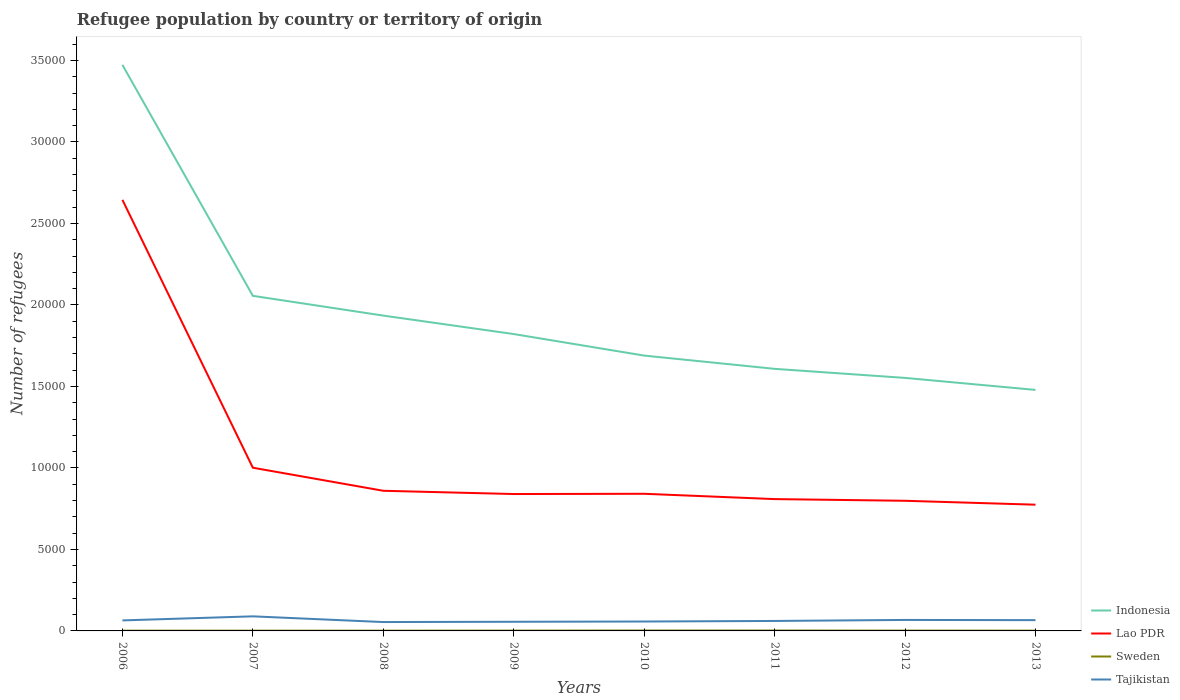Is the number of lines equal to the number of legend labels?
Provide a short and direct response. Yes. Across all years, what is the maximum number of refugees in Tajikistan?
Make the answer very short. 544. What is the total number of refugees in Indonesia in the graph?
Your answer should be compact. 1.65e+04. How many lines are there?
Offer a terse response. 4. How many years are there in the graph?
Offer a very short reply. 8. What is the difference between two consecutive major ticks on the Y-axis?
Provide a short and direct response. 5000. Are the values on the major ticks of Y-axis written in scientific E-notation?
Give a very brief answer. No. Does the graph contain any zero values?
Offer a very short reply. No. Does the graph contain grids?
Provide a short and direct response. No. Where does the legend appear in the graph?
Offer a terse response. Bottom right. How many legend labels are there?
Ensure brevity in your answer.  4. How are the legend labels stacked?
Provide a succinct answer. Vertical. What is the title of the graph?
Make the answer very short. Refugee population by country or territory of origin. What is the label or title of the X-axis?
Your response must be concise. Years. What is the label or title of the Y-axis?
Your response must be concise. Number of refugees. What is the Number of refugees of Indonesia in 2006?
Offer a terse response. 3.47e+04. What is the Number of refugees in Lao PDR in 2006?
Your response must be concise. 2.64e+04. What is the Number of refugees of Sweden in 2006?
Provide a succinct answer. 16. What is the Number of refugees of Tajikistan in 2006?
Your answer should be very brief. 645. What is the Number of refugees in Indonesia in 2007?
Provide a succinct answer. 2.06e+04. What is the Number of refugees in Lao PDR in 2007?
Provide a succinct answer. 1.00e+04. What is the Number of refugees of Sweden in 2007?
Your answer should be very brief. 16. What is the Number of refugees of Tajikistan in 2007?
Offer a terse response. 894. What is the Number of refugees in Indonesia in 2008?
Offer a very short reply. 1.93e+04. What is the Number of refugees in Lao PDR in 2008?
Make the answer very short. 8598. What is the Number of refugees of Tajikistan in 2008?
Provide a short and direct response. 544. What is the Number of refugees of Indonesia in 2009?
Make the answer very short. 1.82e+04. What is the Number of refugees of Lao PDR in 2009?
Make the answer very short. 8398. What is the Number of refugees in Tajikistan in 2009?
Ensure brevity in your answer.  562. What is the Number of refugees in Indonesia in 2010?
Keep it short and to the point. 1.69e+04. What is the Number of refugees of Lao PDR in 2010?
Keep it short and to the point. 8414. What is the Number of refugees of Sweden in 2010?
Make the answer very short. 25. What is the Number of refugees in Tajikistan in 2010?
Ensure brevity in your answer.  577. What is the Number of refugees of Indonesia in 2011?
Offer a terse response. 1.61e+04. What is the Number of refugees in Lao PDR in 2011?
Ensure brevity in your answer.  8088. What is the Number of refugees in Sweden in 2011?
Make the answer very short. 24. What is the Number of refugees of Tajikistan in 2011?
Provide a succinct answer. 612. What is the Number of refugees in Indonesia in 2012?
Offer a very short reply. 1.55e+04. What is the Number of refugees of Lao PDR in 2012?
Ensure brevity in your answer.  7984. What is the Number of refugees of Sweden in 2012?
Offer a terse response. 20. What is the Number of refugees in Tajikistan in 2012?
Ensure brevity in your answer.  674. What is the Number of refugees of Indonesia in 2013?
Provide a succinct answer. 1.48e+04. What is the Number of refugees in Lao PDR in 2013?
Your answer should be very brief. 7745. What is the Number of refugees in Sweden in 2013?
Make the answer very short. 17. What is the Number of refugees of Tajikistan in 2013?
Offer a very short reply. 661. Across all years, what is the maximum Number of refugees in Indonesia?
Your answer should be very brief. 3.47e+04. Across all years, what is the maximum Number of refugees of Lao PDR?
Your answer should be compact. 2.64e+04. Across all years, what is the maximum Number of refugees of Sweden?
Ensure brevity in your answer.  25. Across all years, what is the maximum Number of refugees in Tajikistan?
Your answer should be compact. 894. Across all years, what is the minimum Number of refugees of Indonesia?
Provide a succinct answer. 1.48e+04. Across all years, what is the minimum Number of refugees of Lao PDR?
Provide a succinct answer. 7745. Across all years, what is the minimum Number of refugees of Tajikistan?
Your answer should be compact. 544. What is the total Number of refugees in Indonesia in the graph?
Offer a very short reply. 1.56e+05. What is the total Number of refugees of Lao PDR in the graph?
Your answer should be very brief. 8.57e+04. What is the total Number of refugees in Sweden in the graph?
Keep it short and to the point. 152. What is the total Number of refugees in Tajikistan in the graph?
Give a very brief answer. 5169. What is the difference between the Number of refugees in Indonesia in 2006 and that in 2007?
Make the answer very short. 1.42e+04. What is the difference between the Number of refugees in Lao PDR in 2006 and that in 2007?
Provide a succinct answer. 1.64e+04. What is the difference between the Number of refugees of Sweden in 2006 and that in 2007?
Make the answer very short. 0. What is the difference between the Number of refugees of Tajikistan in 2006 and that in 2007?
Your answer should be very brief. -249. What is the difference between the Number of refugees of Indonesia in 2006 and that in 2008?
Give a very brief answer. 1.54e+04. What is the difference between the Number of refugees in Lao PDR in 2006 and that in 2008?
Offer a very short reply. 1.78e+04. What is the difference between the Number of refugees in Sweden in 2006 and that in 2008?
Make the answer very short. 1. What is the difference between the Number of refugees in Tajikistan in 2006 and that in 2008?
Offer a terse response. 101. What is the difference between the Number of refugees of Indonesia in 2006 and that in 2009?
Your answer should be compact. 1.65e+04. What is the difference between the Number of refugees of Lao PDR in 2006 and that in 2009?
Keep it short and to the point. 1.80e+04. What is the difference between the Number of refugees of Indonesia in 2006 and that in 2010?
Make the answer very short. 1.78e+04. What is the difference between the Number of refugees in Lao PDR in 2006 and that in 2010?
Ensure brevity in your answer.  1.80e+04. What is the difference between the Number of refugees of Sweden in 2006 and that in 2010?
Provide a succinct answer. -9. What is the difference between the Number of refugees in Tajikistan in 2006 and that in 2010?
Provide a short and direct response. 68. What is the difference between the Number of refugees of Indonesia in 2006 and that in 2011?
Keep it short and to the point. 1.86e+04. What is the difference between the Number of refugees in Lao PDR in 2006 and that in 2011?
Offer a terse response. 1.84e+04. What is the difference between the Number of refugees in Sweden in 2006 and that in 2011?
Offer a terse response. -8. What is the difference between the Number of refugees of Tajikistan in 2006 and that in 2011?
Your response must be concise. 33. What is the difference between the Number of refugees of Indonesia in 2006 and that in 2012?
Offer a terse response. 1.92e+04. What is the difference between the Number of refugees of Lao PDR in 2006 and that in 2012?
Give a very brief answer. 1.85e+04. What is the difference between the Number of refugees in Tajikistan in 2006 and that in 2012?
Offer a very short reply. -29. What is the difference between the Number of refugees in Indonesia in 2006 and that in 2013?
Keep it short and to the point. 1.99e+04. What is the difference between the Number of refugees in Lao PDR in 2006 and that in 2013?
Your response must be concise. 1.87e+04. What is the difference between the Number of refugees in Indonesia in 2007 and that in 2008?
Give a very brief answer. 1213. What is the difference between the Number of refugees of Lao PDR in 2007 and that in 2008?
Your answer should be compact. 1415. What is the difference between the Number of refugees of Sweden in 2007 and that in 2008?
Provide a short and direct response. 1. What is the difference between the Number of refugees of Tajikistan in 2007 and that in 2008?
Make the answer very short. 350. What is the difference between the Number of refugees in Indonesia in 2007 and that in 2009?
Your answer should be very brief. 2345. What is the difference between the Number of refugees of Lao PDR in 2007 and that in 2009?
Give a very brief answer. 1615. What is the difference between the Number of refugees in Tajikistan in 2007 and that in 2009?
Offer a very short reply. 332. What is the difference between the Number of refugees of Indonesia in 2007 and that in 2010?
Provide a short and direct response. 3666. What is the difference between the Number of refugees in Lao PDR in 2007 and that in 2010?
Provide a succinct answer. 1599. What is the difference between the Number of refugees of Sweden in 2007 and that in 2010?
Ensure brevity in your answer.  -9. What is the difference between the Number of refugees in Tajikistan in 2007 and that in 2010?
Your answer should be compact. 317. What is the difference between the Number of refugees in Indonesia in 2007 and that in 2011?
Your answer should be compact. 4479. What is the difference between the Number of refugees in Lao PDR in 2007 and that in 2011?
Your answer should be very brief. 1925. What is the difference between the Number of refugees in Sweden in 2007 and that in 2011?
Offer a very short reply. -8. What is the difference between the Number of refugees in Tajikistan in 2007 and that in 2011?
Provide a short and direct response. 282. What is the difference between the Number of refugees in Indonesia in 2007 and that in 2012?
Your response must be concise. 5035. What is the difference between the Number of refugees of Lao PDR in 2007 and that in 2012?
Provide a short and direct response. 2029. What is the difference between the Number of refugees of Sweden in 2007 and that in 2012?
Provide a short and direct response. -4. What is the difference between the Number of refugees of Tajikistan in 2007 and that in 2012?
Offer a very short reply. 220. What is the difference between the Number of refugees in Indonesia in 2007 and that in 2013?
Provide a succinct answer. 5772. What is the difference between the Number of refugees of Lao PDR in 2007 and that in 2013?
Offer a very short reply. 2268. What is the difference between the Number of refugees in Tajikistan in 2007 and that in 2013?
Give a very brief answer. 233. What is the difference between the Number of refugees of Indonesia in 2008 and that in 2009?
Your answer should be compact. 1132. What is the difference between the Number of refugees of Lao PDR in 2008 and that in 2009?
Ensure brevity in your answer.  200. What is the difference between the Number of refugees of Indonesia in 2008 and that in 2010?
Your answer should be compact. 2453. What is the difference between the Number of refugees in Lao PDR in 2008 and that in 2010?
Offer a terse response. 184. What is the difference between the Number of refugees of Tajikistan in 2008 and that in 2010?
Your answer should be very brief. -33. What is the difference between the Number of refugees of Indonesia in 2008 and that in 2011?
Give a very brief answer. 3266. What is the difference between the Number of refugees of Lao PDR in 2008 and that in 2011?
Ensure brevity in your answer.  510. What is the difference between the Number of refugees in Tajikistan in 2008 and that in 2011?
Provide a short and direct response. -68. What is the difference between the Number of refugees of Indonesia in 2008 and that in 2012?
Your answer should be very brief. 3822. What is the difference between the Number of refugees in Lao PDR in 2008 and that in 2012?
Your response must be concise. 614. What is the difference between the Number of refugees in Sweden in 2008 and that in 2012?
Offer a very short reply. -5. What is the difference between the Number of refugees of Tajikistan in 2008 and that in 2012?
Keep it short and to the point. -130. What is the difference between the Number of refugees in Indonesia in 2008 and that in 2013?
Ensure brevity in your answer.  4559. What is the difference between the Number of refugees of Lao PDR in 2008 and that in 2013?
Your answer should be very brief. 853. What is the difference between the Number of refugees in Tajikistan in 2008 and that in 2013?
Offer a very short reply. -117. What is the difference between the Number of refugees of Indonesia in 2009 and that in 2010?
Make the answer very short. 1321. What is the difference between the Number of refugees in Lao PDR in 2009 and that in 2010?
Offer a terse response. -16. What is the difference between the Number of refugees in Tajikistan in 2009 and that in 2010?
Make the answer very short. -15. What is the difference between the Number of refugees of Indonesia in 2009 and that in 2011?
Offer a very short reply. 2134. What is the difference between the Number of refugees of Lao PDR in 2009 and that in 2011?
Offer a terse response. 310. What is the difference between the Number of refugees in Tajikistan in 2009 and that in 2011?
Ensure brevity in your answer.  -50. What is the difference between the Number of refugees of Indonesia in 2009 and that in 2012?
Ensure brevity in your answer.  2690. What is the difference between the Number of refugees of Lao PDR in 2009 and that in 2012?
Offer a very short reply. 414. What is the difference between the Number of refugees in Sweden in 2009 and that in 2012?
Provide a short and direct response. -1. What is the difference between the Number of refugees in Tajikistan in 2009 and that in 2012?
Keep it short and to the point. -112. What is the difference between the Number of refugees in Indonesia in 2009 and that in 2013?
Ensure brevity in your answer.  3427. What is the difference between the Number of refugees of Lao PDR in 2009 and that in 2013?
Offer a terse response. 653. What is the difference between the Number of refugees in Sweden in 2009 and that in 2013?
Your response must be concise. 2. What is the difference between the Number of refugees of Tajikistan in 2009 and that in 2013?
Make the answer very short. -99. What is the difference between the Number of refugees in Indonesia in 2010 and that in 2011?
Offer a terse response. 813. What is the difference between the Number of refugees of Lao PDR in 2010 and that in 2011?
Make the answer very short. 326. What is the difference between the Number of refugees in Tajikistan in 2010 and that in 2011?
Provide a succinct answer. -35. What is the difference between the Number of refugees in Indonesia in 2010 and that in 2012?
Offer a terse response. 1369. What is the difference between the Number of refugees of Lao PDR in 2010 and that in 2012?
Your answer should be very brief. 430. What is the difference between the Number of refugees of Tajikistan in 2010 and that in 2012?
Make the answer very short. -97. What is the difference between the Number of refugees in Indonesia in 2010 and that in 2013?
Keep it short and to the point. 2106. What is the difference between the Number of refugees in Lao PDR in 2010 and that in 2013?
Your answer should be very brief. 669. What is the difference between the Number of refugees in Sweden in 2010 and that in 2013?
Give a very brief answer. 8. What is the difference between the Number of refugees of Tajikistan in 2010 and that in 2013?
Ensure brevity in your answer.  -84. What is the difference between the Number of refugees of Indonesia in 2011 and that in 2012?
Your answer should be very brief. 556. What is the difference between the Number of refugees in Lao PDR in 2011 and that in 2012?
Make the answer very short. 104. What is the difference between the Number of refugees of Tajikistan in 2011 and that in 2012?
Keep it short and to the point. -62. What is the difference between the Number of refugees of Indonesia in 2011 and that in 2013?
Make the answer very short. 1293. What is the difference between the Number of refugees of Lao PDR in 2011 and that in 2013?
Ensure brevity in your answer.  343. What is the difference between the Number of refugees in Sweden in 2011 and that in 2013?
Provide a succinct answer. 7. What is the difference between the Number of refugees of Tajikistan in 2011 and that in 2013?
Provide a short and direct response. -49. What is the difference between the Number of refugees of Indonesia in 2012 and that in 2013?
Provide a short and direct response. 737. What is the difference between the Number of refugees in Lao PDR in 2012 and that in 2013?
Ensure brevity in your answer.  239. What is the difference between the Number of refugees of Indonesia in 2006 and the Number of refugees of Lao PDR in 2007?
Your response must be concise. 2.47e+04. What is the difference between the Number of refugees of Indonesia in 2006 and the Number of refugees of Sweden in 2007?
Ensure brevity in your answer.  3.47e+04. What is the difference between the Number of refugees of Indonesia in 2006 and the Number of refugees of Tajikistan in 2007?
Provide a short and direct response. 3.38e+04. What is the difference between the Number of refugees in Lao PDR in 2006 and the Number of refugees in Sweden in 2007?
Give a very brief answer. 2.64e+04. What is the difference between the Number of refugees of Lao PDR in 2006 and the Number of refugees of Tajikistan in 2007?
Provide a succinct answer. 2.56e+04. What is the difference between the Number of refugees in Sweden in 2006 and the Number of refugees in Tajikistan in 2007?
Offer a terse response. -878. What is the difference between the Number of refugees of Indonesia in 2006 and the Number of refugees of Lao PDR in 2008?
Ensure brevity in your answer.  2.61e+04. What is the difference between the Number of refugees of Indonesia in 2006 and the Number of refugees of Sweden in 2008?
Give a very brief answer. 3.47e+04. What is the difference between the Number of refugees of Indonesia in 2006 and the Number of refugees of Tajikistan in 2008?
Give a very brief answer. 3.42e+04. What is the difference between the Number of refugees of Lao PDR in 2006 and the Number of refugees of Sweden in 2008?
Keep it short and to the point. 2.64e+04. What is the difference between the Number of refugees of Lao PDR in 2006 and the Number of refugees of Tajikistan in 2008?
Ensure brevity in your answer.  2.59e+04. What is the difference between the Number of refugees in Sweden in 2006 and the Number of refugees in Tajikistan in 2008?
Your answer should be compact. -528. What is the difference between the Number of refugees in Indonesia in 2006 and the Number of refugees in Lao PDR in 2009?
Offer a very short reply. 2.63e+04. What is the difference between the Number of refugees in Indonesia in 2006 and the Number of refugees in Sweden in 2009?
Offer a very short reply. 3.47e+04. What is the difference between the Number of refugees in Indonesia in 2006 and the Number of refugees in Tajikistan in 2009?
Ensure brevity in your answer.  3.42e+04. What is the difference between the Number of refugees in Lao PDR in 2006 and the Number of refugees in Sweden in 2009?
Ensure brevity in your answer.  2.64e+04. What is the difference between the Number of refugees in Lao PDR in 2006 and the Number of refugees in Tajikistan in 2009?
Make the answer very short. 2.59e+04. What is the difference between the Number of refugees of Sweden in 2006 and the Number of refugees of Tajikistan in 2009?
Ensure brevity in your answer.  -546. What is the difference between the Number of refugees in Indonesia in 2006 and the Number of refugees in Lao PDR in 2010?
Provide a succinct answer. 2.63e+04. What is the difference between the Number of refugees in Indonesia in 2006 and the Number of refugees in Sweden in 2010?
Keep it short and to the point. 3.47e+04. What is the difference between the Number of refugees of Indonesia in 2006 and the Number of refugees of Tajikistan in 2010?
Offer a terse response. 3.42e+04. What is the difference between the Number of refugees in Lao PDR in 2006 and the Number of refugees in Sweden in 2010?
Your response must be concise. 2.64e+04. What is the difference between the Number of refugees in Lao PDR in 2006 and the Number of refugees in Tajikistan in 2010?
Offer a terse response. 2.59e+04. What is the difference between the Number of refugees in Sweden in 2006 and the Number of refugees in Tajikistan in 2010?
Make the answer very short. -561. What is the difference between the Number of refugees in Indonesia in 2006 and the Number of refugees in Lao PDR in 2011?
Ensure brevity in your answer.  2.66e+04. What is the difference between the Number of refugees in Indonesia in 2006 and the Number of refugees in Sweden in 2011?
Your answer should be compact. 3.47e+04. What is the difference between the Number of refugees in Indonesia in 2006 and the Number of refugees in Tajikistan in 2011?
Your answer should be very brief. 3.41e+04. What is the difference between the Number of refugees of Lao PDR in 2006 and the Number of refugees of Sweden in 2011?
Your answer should be very brief. 2.64e+04. What is the difference between the Number of refugees in Lao PDR in 2006 and the Number of refugees in Tajikistan in 2011?
Provide a short and direct response. 2.58e+04. What is the difference between the Number of refugees in Sweden in 2006 and the Number of refugees in Tajikistan in 2011?
Your answer should be very brief. -596. What is the difference between the Number of refugees of Indonesia in 2006 and the Number of refugees of Lao PDR in 2012?
Keep it short and to the point. 2.67e+04. What is the difference between the Number of refugees of Indonesia in 2006 and the Number of refugees of Sweden in 2012?
Your answer should be compact. 3.47e+04. What is the difference between the Number of refugees in Indonesia in 2006 and the Number of refugees in Tajikistan in 2012?
Your answer should be very brief. 3.41e+04. What is the difference between the Number of refugees in Lao PDR in 2006 and the Number of refugees in Sweden in 2012?
Provide a short and direct response. 2.64e+04. What is the difference between the Number of refugees of Lao PDR in 2006 and the Number of refugees of Tajikistan in 2012?
Ensure brevity in your answer.  2.58e+04. What is the difference between the Number of refugees in Sweden in 2006 and the Number of refugees in Tajikistan in 2012?
Your answer should be very brief. -658. What is the difference between the Number of refugees of Indonesia in 2006 and the Number of refugees of Lao PDR in 2013?
Make the answer very short. 2.70e+04. What is the difference between the Number of refugees in Indonesia in 2006 and the Number of refugees in Sweden in 2013?
Give a very brief answer. 3.47e+04. What is the difference between the Number of refugees of Indonesia in 2006 and the Number of refugees of Tajikistan in 2013?
Make the answer very short. 3.41e+04. What is the difference between the Number of refugees in Lao PDR in 2006 and the Number of refugees in Sweden in 2013?
Keep it short and to the point. 2.64e+04. What is the difference between the Number of refugees in Lao PDR in 2006 and the Number of refugees in Tajikistan in 2013?
Ensure brevity in your answer.  2.58e+04. What is the difference between the Number of refugees of Sweden in 2006 and the Number of refugees of Tajikistan in 2013?
Provide a succinct answer. -645. What is the difference between the Number of refugees in Indonesia in 2007 and the Number of refugees in Lao PDR in 2008?
Provide a succinct answer. 1.20e+04. What is the difference between the Number of refugees of Indonesia in 2007 and the Number of refugees of Sweden in 2008?
Your answer should be compact. 2.05e+04. What is the difference between the Number of refugees of Indonesia in 2007 and the Number of refugees of Tajikistan in 2008?
Offer a terse response. 2.00e+04. What is the difference between the Number of refugees of Lao PDR in 2007 and the Number of refugees of Sweden in 2008?
Give a very brief answer. 9998. What is the difference between the Number of refugees of Lao PDR in 2007 and the Number of refugees of Tajikistan in 2008?
Your answer should be very brief. 9469. What is the difference between the Number of refugees of Sweden in 2007 and the Number of refugees of Tajikistan in 2008?
Your answer should be compact. -528. What is the difference between the Number of refugees of Indonesia in 2007 and the Number of refugees of Lao PDR in 2009?
Your answer should be compact. 1.22e+04. What is the difference between the Number of refugees in Indonesia in 2007 and the Number of refugees in Sweden in 2009?
Ensure brevity in your answer.  2.05e+04. What is the difference between the Number of refugees of Indonesia in 2007 and the Number of refugees of Tajikistan in 2009?
Your answer should be very brief. 2.00e+04. What is the difference between the Number of refugees of Lao PDR in 2007 and the Number of refugees of Sweden in 2009?
Keep it short and to the point. 9994. What is the difference between the Number of refugees in Lao PDR in 2007 and the Number of refugees in Tajikistan in 2009?
Your answer should be very brief. 9451. What is the difference between the Number of refugees of Sweden in 2007 and the Number of refugees of Tajikistan in 2009?
Your answer should be very brief. -546. What is the difference between the Number of refugees of Indonesia in 2007 and the Number of refugees of Lao PDR in 2010?
Make the answer very short. 1.21e+04. What is the difference between the Number of refugees in Indonesia in 2007 and the Number of refugees in Sweden in 2010?
Your answer should be compact. 2.05e+04. What is the difference between the Number of refugees in Indonesia in 2007 and the Number of refugees in Tajikistan in 2010?
Your answer should be compact. 2.00e+04. What is the difference between the Number of refugees of Lao PDR in 2007 and the Number of refugees of Sweden in 2010?
Offer a very short reply. 9988. What is the difference between the Number of refugees of Lao PDR in 2007 and the Number of refugees of Tajikistan in 2010?
Ensure brevity in your answer.  9436. What is the difference between the Number of refugees of Sweden in 2007 and the Number of refugees of Tajikistan in 2010?
Your answer should be compact. -561. What is the difference between the Number of refugees of Indonesia in 2007 and the Number of refugees of Lao PDR in 2011?
Offer a very short reply. 1.25e+04. What is the difference between the Number of refugees of Indonesia in 2007 and the Number of refugees of Sweden in 2011?
Offer a very short reply. 2.05e+04. What is the difference between the Number of refugees of Indonesia in 2007 and the Number of refugees of Tajikistan in 2011?
Give a very brief answer. 1.99e+04. What is the difference between the Number of refugees in Lao PDR in 2007 and the Number of refugees in Sweden in 2011?
Provide a short and direct response. 9989. What is the difference between the Number of refugees of Lao PDR in 2007 and the Number of refugees of Tajikistan in 2011?
Offer a terse response. 9401. What is the difference between the Number of refugees of Sweden in 2007 and the Number of refugees of Tajikistan in 2011?
Your response must be concise. -596. What is the difference between the Number of refugees in Indonesia in 2007 and the Number of refugees in Lao PDR in 2012?
Offer a very short reply. 1.26e+04. What is the difference between the Number of refugees in Indonesia in 2007 and the Number of refugees in Sweden in 2012?
Your response must be concise. 2.05e+04. What is the difference between the Number of refugees of Indonesia in 2007 and the Number of refugees of Tajikistan in 2012?
Offer a very short reply. 1.99e+04. What is the difference between the Number of refugees of Lao PDR in 2007 and the Number of refugees of Sweden in 2012?
Your answer should be very brief. 9993. What is the difference between the Number of refugees in Lao PDR in 2007 and the Number of refugees in Tajikistan in 2012?
Keep it short and to the point. 9339. What is the difference between the Number of refugees of Sweden in 2007 and the Number of refugees of Tajikistan in 2012?
Offer a terse response. -658. What is the difference between the Number of refugees of Indonesia in 2007 and the Number of refugees of Lao PDR in 2013?
Provide a short and direct response. 1.28e+04. What is the difference between the Number of refugees of Indonesia in 2007 and the Number of refugees of Sweden in 2013?
Keep it short and to the point. 2.05e+04. What is the difference between the Number of refugees in Indonesia in 2007 and the Number of refugees in Tajikistan in 2013?
Give a very brief answer. 1.99e+04. What is the difference between the Number of refugees of Lao PDR in 2007 and the Number of refugees of Sweden in 2013?
Provide a short and direct response. 9996. What is the difference between the Number of refugees in Lao PDR in 2007 and the Number of refugees in Tajikistan in 2013?
Provide a short and direct response. 9352. What is the difference between the Number of refugees in Sweden in 2007 and the Number of refugees in Tajikistan in 2013?
Give a very brief answer. -645. What is the difference between the Number of refugees of Indonesia in 2008 and the Number of refugees of Lao PDR in 2009?
Your response must be concise. 1.09e+04. What is the difference between the Number of refugees in Indonesia in 2008 and the Number of refugees in Sweden in 2009?
Offer a very short reply. 1.93e+04. What is the difference between the Number of refugees of Indonesia in 2008 and the Number of refugees of Tajikistan in 2009?
Provide a short and direct response. 1.88e+04. What is the difference between the Number of refugees in Lao PDR in 2008 and the Number of refugees in Sweden in 2009?
Your answer should be very brief. 8579. What is the difference between the Number of refugees of Lao PDR in 2008 and the Number of refugees of Tajikistan in 2009?
Your answer should be very brief. 8036. What is the difference between the Number of refugees in Sweden in 2008 and the Number of refugees in Tajikistan in 2009?
Provide a short and direct response. -547. What is the difference between the Number of refugees in Indonesia in 2008 and the Number of refugees in Lao PDR in 2010?
Your answer should be compact. 1.09e+04. What is the difference between the Number of refugees in Indonesia in 2008 and the Number of refugees in Sweden in 2010?
Offer a very short reply. 1.93e+04. What is the difference between the Number of refugees in Indonesia in 2008 and the Number of refugees in Tajikistan in 2010?
Offer a terse response. 1.88e+04. What is the difference between the Number of refugees in Lao PDR in 2008 and the Number of refugees in Sweden in 2010?
Your answer should be compact. 8573. What is the difference between the Number of refugees in Lao PDR in 2008 and the Number of refugees in Tajikistan in 2010?
Offer a terse response. 8021. What is the difference between the Number of refugees in Sweden in 2008 and the Number of refugees in Tajikistan in 2010?
Keep it short and to the point. -562. What is the difference between the Number of refugees of Indonesia in 2008 and the Number of refugees of Lao PDR in 2011?
Offer a very short reply. 1.13e+04. What is the difference between the Number of refugees in Indonesia in 2008 and the Number of refugees in Sweden in 2011?
Provide a succinct answer. 1.93e+04. What is the difference between the Number of refugees of Indonesia in 2008 and the Number of refugees of Tajikistan in 2011?
Your answer should be very brief. 1.87e+04. What is the difference between the Number of refugees in Lao PDR in 2008 and the Number of refugees in Sweden in 2011?
Provide a short and direct response. 8574. What is the difference between the Number of refugees of Lao PDR in 2008 and the Number of refugees of Tajikistan in 2011?
Offer a very short reply. 7986. What is the difference between the Number of refugees of Sweden in 2008 and the Number of refugees of Tajikistan in 2011?
Your answer should be very brief. -597. What is the difference between the Number of refugees of Indonesia in 2008 and the Number of refugees of Lao PDR in 2012?
Give a very brief answer. 1.14e+04. What is the difference between the Number of refugees in Indonesia in 2008 and the Number of refugees in Sweden in 2012?
Your response must be concise. 1.93e+04. What is the difference between the Number of refugees in Indonesia in 2008 and the Number of refugees in Tajikistan in 2012?
Your answer should be very brief. 1.87e+04. What is the difference between the Number of refugees in Lao PDR in 2008 and the Number of refugees in Sweden in 2012?
Give a very brief answer. 8578. What is the difference between the Number of refugees of Lao PDR in 2008 and the Number of refugees of Tajikistan in 2012?
Your response must be concise. 7924. What is the difference between the Number of refugees in Sweden in 2008 and the Number of refugees in Tajikistan in 2012?
Make the answer very short. -659. What is the difference between the Number of refugees of Indonesia in 2008 and the Number of refugees of Lao PDR in 2013?
Your response must be concise. 1.16e+04. What is the difference between the Number of refugees of Indonesia in 2008 and the Number of refugees of Sweden in 2013?
Give a very brief answer. 1.93e+04. What is the difference between the Number of refugees of Indonesia in 2008 and the Number of refugees of Tajikistan in 2013?
Make the answer very short. 1.87e+04. What is the difference between the Number of refugees in Lao PDR in 2008 and the Number of refugees in Sweden in 2013?
Give a very brief answer. 8581. What is the difference between the Number of refugees in Lao PDR in 2008 and the Number of refugees in Tajikistan in 2013?
Your answer should be compact. 7937. What is the difference between the Number of refugees of Sweden in 2008 and the Number of refugees of Tajikistan in 2013?
Keep it short and to the point. -646. What is the difference between the Number of refugees of Indonesia in 2009 and the Number of refugees of Lao PDR in 2010?
Make the answer very short. 9799. What is the difference between the Number of refugees of Indonesia in 2009 and the Number of refugees of Sweden in 2010?
Your answer should be compact. 1.82e+04. What is the difference between the Number of refugees of Indonesia in 2009 and the Number of refugees of Tajikistan in 2010?
Provide a short and direct response. 1.76e+04. What is the difference between the Number of refugees of Lao PDR in 2009 and the Number of refugees of Sweden in 2010?
Give a very brief answer. 8373. What is the difference between the Number of refugees of Lao PDR in 2009 and the Number of refugees of Tajikistan in 2010?
Make the answer very short. 7821. What is the difference between the Number of refugees of Sweden in 2009 and the Number of refugees of Tajikistan in 2010?
Offer a very short reply. -558. What is the difference between the Number of refugees of Indonesia in 2009 and the Number of refugees of Lao PDR in 2011?
Offer a very short reply. 1.01e+04. What is the difference between the Number of refugees in Indonesia in 2009 and the Number of refugees in Sweden in 2011?
Offer a very short reply. 1.82e+04. What is the difference between the Number of refugees of Indonesia in 2009 and the Number of refugees of Tajikistan in 2011?
Your answer should be very brief. 1.76e+04. What is the difference between the Number of refugees in Lao PDR in 2009 and the Number of refugees in Sweden in 2011?
Your answer should be compact. 8374. What is the difference between the Number of refugees of Lao PDR in 2009 and the Number of refugees of Tajikistan in 2011?
Give a very brief answer. 7786. What is the difference between the Number of refugees of Sweden in 2009 and the Number of refugees of Tajikistan in 2011?
Provide a short and direct response. -593. What is the difference between the Number of refugees in Indonesia in 2009 and the Number of refugees in Lao PDR in 2012?
Your answer should be compact. 1.02e+04. What is the difference between the Number of refugees of Indonesia in 2009 and the Number of refugees of Sweden in 2012?
Offer a terse response. 1.82e+04. What is the difference between the Number of refugees of Indonesia in 2009 and the Number of refugees of Tajikistan in 2012?
Offer a terse response. 1.75e+04. What is the difference between the Number of refugees of Lao PDR in 2009 and the Number of refugees of Sweden in 2012?
Ensure brevity in your answer.  8378. What is the difference between the Number of refugees of Lao PDR in 2009 and the Number of refugees of Tajikistan in 2012?
Ensure brevity in your answer.  7724. What is the difference between the Number of refugees in Sweden in 2009 and the Number of refugees in Tajikistan in 2012?
Your answer should be very brief. -655. What is the difference between the Number of refugees in Indonesia in 2009 and the Number of refugees in Lao PDR in 2013?
Provide a succinct answer. 1.05e+04. What is the difference between the Number of refugees in Indonesia in 2009 and the Number of refugees in Sweden in 2013?
Provide a succinct answer. 1.82e+04. What is the difference between the Number of refugees of Indonesia in 2009 and the Number of refugees of Tajikistan in 2013?
Give a very brief answer. 1.76e+04. What is the difference between the Number of refugees in Lao PDR in 2009 and the Number of refugees in Sweden in 2013?
Ensure brevity in your answer.  8381. What is the difference between the Number of refugees in Lao PDR in 2009 and the Number of refugees in Tajikistan in 2013?
Offer a very short reply. 7737. What is the difference between the Number of refugees of Sweden in 2009 and the Number of refugees of Tajikistan in 2013?
Offer a terse response. -642. What is the difference between the Number of refugees in Indonesia in 2010 and the Number of refugees in Lao PDR in 2011?
Offer a very short reply. 8804. What is the difference between the Number of refugees of Indonesia in 2010 and the Number of refugees of Sweden in 2011?
Your response must be concise. 1.69e+04. What is the difference between the Number of refugees of Indonesia in 2010 and the Number of refugees of Tajikistan in 2011?
Your answer should be compact. 1.63e+04. What is the difference between the Number of refugees in Lao PDR in 2010 and the Number of refugees in Sweden in 2011?
Your answer should be very brief. 8390. What is the difference between the Number of refugees in Lao PDR in 2010 and the Number of refugees in Tajikistan in 2011?
Your answer should be very brief. 7802. What is the difference between the Number of refugees in Sweden in 2010 and the Number of refugees in Tajikistan in 2011?
Offer a terse response. -587. What is the difference between the Number of refugees in Indonesia in 2010 and the Number of refugees in Lao PDR in 2012?
Offer a very short reply. 8908. What is the difference between the Number of refugees of Indonesia in 2010 and the Number of refugees of Sweden in 2012?
Provide a succinct answer. 1.69e+04. What is the difference between the Number of refugees of Indonesia in 2010 and the Number of refugees of Tajikistan in 2012?
Give a very brief answer. 1.62e+04. What is the difference between the Number of refugees of Lao PDR in 2010 and the Number of refugees of Sweden in 2012?
Your response must be concise. 8394. What is the difference between the Number of refugees in Lao PDR in 2010 and the Number of refugees in Tajikistan in 2012?
Your answer should be very brief. 7740. What is the difference between the Number of refugees of Sweden in 2010 and the Number of refugees of Tajikistan in 2012?
Give a very brief answer. -649. What is the difference between the Number of refugees of Indonesia in 2010 and the Number of refugees of Lao PDR in 2013?
Your answer should be very brief. 9147. What is the difference between the Number of refugees in Indonesia in 2010 and the Number of refugees in Sweden in 2013?
Make the answer very short. 1.69e+04. What is the difference between the Number of refugees of Indonesia in 2010 and the Number of refugees of Tajikistan in 2013?
Make the answer very short. 1.62e+04. What is the difference between the Number of refugees in Lao PDR in 2010 and the Number of refugees in Sweden in 2013?
Your response must be concise. 8397. What is the difference between the Number of refugees of Lao PDR in 2010 and the Number of refugees of Tajikistan in 2013?
Offer a very short reply. 7753. What is the difference between the Number of refugees in Sweden in 2010 and the Number of refugees in Tajikistan in 2013?
Provide a short and direct response. -636. What is the difference between the Number of refugees of Indonesia in 2011 and the Number of refugees of Lao PDR in 2012?
Offer a terse response. 8095. What is the difference between the Number of refugees of Indonesia in 2011 and the Number of refugees of Sweden in 2012?
Provide a succinct answer. 1.61e+04. What is the difference between the Number of refugees of Indonesia in 2011 and the Number of refugees of Tajikistan in 2012?
Your answer should be compact. 1.54e+04. What is the difference between the Number of refugees of Lao PDR in 2011 and the Number of refugees of Sweden in 2012?
Ensure brevity in your answer.  8068. What is the difference between the Number of refugees in Lao PDR in 2011 and the Number of refugees in Tajikistan in 2012?
Give a very brief answer. 7414. What is the difference between the Number of refugees of Sweden in 2011 and the Number of refugees of Tajikistan in 2012?
Your response must be concise. -650. What is the difference between the Number of refugees of Indonesia in 2011 and the Number of refugees of Lao PDR in 2013?
Provide a succinct answer. 8334. What is the difference between the Number of refugees in Indonesia in 2011 and the Number of refugees in Sweden in 2013?
Provide a short and direct response. 1.61e+04. What is the difference between the Number of refugees in Indonesia in 2011 and the Number of refugees in Tajikistan in 2013?
Your response must be concise. 1.54e+04. What is the difference between the Number of refugees of Lao PDR in 2011 and the Number of refugees of Sweden in 2013?
Keep it short and to the point. 8071. What is the difference between the Number of refugees in Lao PDR in 2011 and the Number of refugees in Tajikistan in 2013?
Provide a short and direct response. 7427. What is the difference between the Number of refugees in Sweden in 2011 and the Number of refugees in Tajikistan in 2013?
Make the answer very short. -637. What is the difference between the Number of refugees in Indonesia in 2012 and the Number of refugees in Lao PDR in 2013?
Ensure brevity in your answer.  7778. What is the difference between the Number of refugees of Indonesia in 2012 and the Number of refugees of Sweden in 2013?
Offer a very short reply. 1.55e+04. What is the difference between the Number of refugees of Indonesia in 2012 and the Number of refugees of Tajikistan in 2013?
Make the answer very short. 1.49e+04. What is the difference between the Number of refugees of Lao PDR in 2012 and the Number of refugees of Sweden in 2013?
Offer a very short reply. 7967. What is the difference between the Number of refugees in Lao PDR in 2012 and the Number of refugees in Tajikistan in 2013?
Your response must be concise. 7323. What is the difference between the Number of refugees of Sweden in 2012 and the Number of refugees of Tajikistan in 2013?
Give a very brief answer. -641. What is the average Number of refugees of Indonesia per year?
Give a very brief answer. 1.95e+04. What is the average Number of refugees of Lao PDR per year?
Your answer should be compact. 1.07e+04. What is the average Number of refugees in Tajikistan per year?
Make the answer very short. 646.12. In the year 2006, what is the difference between the Number of refugees of Indonesia and Number of refugees of Lao PDR?
Your answer should be compact. 8281. In the year 2006, what is the difference between the Number of refugees in Indonesia and Number of refugees in Sweden?
Ensure brevity in your answer.  3.47e+04. In the year 2006, what is the difference between the Number of refugees in Indonesia and Number of refugees in Tajikistan?
Provide a succinct answer. 3.41e+04. In the year 2006, what is the difference between the Number of refugees of Lao PDR and Number of refugees of Sweden?
Provide a short and direct response. 2.64e+04. In the year 2006, what is the difference between the Number of refugees in Lao PDR and Number of refugees in Tajikistan?
Ensure brevity in your answer.  2.58e+04. In the year 2006, what is the difference between the Number of refugees in Sweden and Number of refugees in Tajikistan?
Offer a very short reply. -629. In the year 2007, what is the difference between the Number of refugees of Indonesia and Number of refugees of Lao PDR?
Keep it short and to the point. 1.05e+04. In the year 2007, what is the difference between the Number of refugees of Indonesia and Number of refugees of Sweden?
Provide a short and direct response. 2.05e+04. In the year 2007, what is the difference between the Number of refugees of Indonesia and Number of refugees of Tajikistan?
Provide a short and direct response. 1.97e+04. In the year 2007, what is the difference between the Number of refugees of Lao PDR and Number of refugees of Sweden?
Make the answer very short. 9997. In the year 2007, what is the difference between the Number of refugees in Lao PDR and Number of refugees in Tajikistan?
Your response must be concise. 9119. In the year 2007, what is the difference between the Number of refugees in Sweden and Number of refugees in Tajikistan?
Keep it short and to the point. -878. In the year 2008, what is the difference between the Number of refugees of Indonesia and Number of refugees of Lao PDR?
Provide a succinct answer. 1.07e+04. In the year 2008, what is the difference between the Number of refugees in Indonesia and Number of refugees in Sweden?
Make the answer very short. 1.93e+04. In the year 2008, what is the difference between the Number of refugees of Indonesia and Number of refugees of Tajikistan?
Your answer should be compact. 1.88e+04. In the year 2008, what is the difference between the Number of refugees of Lao PDR and Number of refugees of Sweden?
Give a very brief answer. 8583. In the year 2008, what is the difference between the Number of refugees in Lao PDR and Number of refugees in Tajikistan?
Offer a very short reply. 8054. In the year 2008, what is the difference between the Number of refugees of Sweden and Number of refugees of Tajikistan?
Your answer should be very brief. -529. In the year 2009, what is the difference between the Number of refugees in Indonesia and Number of refugees in Lao PDR?
Offer a very short reply. 9815. In the year 2009, what is the difference between the Number of refugees of Indonesia and Number of refugees of Sweden?
Ensure brevity in your answer.  1.82e+04. In the year 2009, what is the difference between the Number of refugees of Indonesia and Number of refugees of Tajikistan?
Give a very brief answer. 1.77e+04. In the year 2009, what is the difference between the Number of refugees in Lao PDR and Number of refugees in Sweden?
Offer a terse response. 8379. In the year 2009, what is the difference between the Number of refugees of Lao PDR and Number of refugees of Tajikistan?
Provide a succinct answer. 7836. In the year 2009, what is the difference between the Number of refugees in Sweden and Number of refugees in Tajikistan?
Your answer should be compact. -543. In the year 2010, what is the difference between the Number of refugees in Indonesia and Number of refugees in Lao PDR?
Your answer should be very brief. 8478. In the year 2010, what is the difference between the Number of refugees in Indonesia and Number of refugees in Sweden?
Offer a very short reply. 1.69e+04. In the year 2010, what is the difference between the Number of refugees in Indonesia and Number of refugees in Tajikistan?
Keep it short and to the point. 1.63e+04. In the year 2010, what is the difference between the Number of refugees of Lao PDR and Number of refugees of Sweden?
Provide a short and direct response. 8389. In the year 2010, what is the difference between the Number of refugees of Lao PDR and Number of refugees of Tajikistan?
Your response must be concise. 7837. In the year 2010, what is the difference between the Number of refugees in Sweden and Number of refugees in Tajikistan?
Provide a short and direct response. -552. In the year 2011, what is the difference between the Number of refugees in Indonesia and Number of refugees in Lao PDR?
Your response must be concise. 7991. In the year 2011, what is the difference between the Number of refugees in Indonesia and Number of refugees in Sweden?
Keep it short and to the point. 1.61e+04. In the year 2011, what is the difference between the Number of refugees in Indonesia and Number of refugees in Tajikistan?
Keep it short and to the point. 1.55e+04. In the year 2011, what is the difference between the Number of refugees in Lao PDR and Number of refugees in Sweden?
Keep it short and to the point. 8064. In the year 2011, what is the difference between the Number of refugees in Lao PDR and Number of refugees in Tajikistan?
Offer a terse response. 7476. In the year 2011, what is the difference between the Number of refugees of Sweden and Number of refugees of Tajikistan?
Provide a short and direct response. -588. In the year 2012, what is the difference between the Number of refugees in Indonesia and Number of refugees in Lao PDR?
Offer a very short reply. 7539. In the year 2012, what is the difference between the Number of refugees in Indonesia and Number of refugees in Sweden?
Make the answer very short. 1.55e+04. In the year 2012, what is the difference between the Number of refugees in Indonesia and Number of refugees in Tajikistan?
Keep it short and to the point. 1.48e+04. In the year 2012, what is the difference between the Number of refugees of Lao PDR and Number of refugees of Sweden?
Give a very brief answer. 7964. In the year 2012, what is the difference between the Number of refugees in Lao PDR and Number of refugees in Tajikistan?
Keep it short and to the point. 7310. In the year 2012, what is the difference between the Number of refugees of Sweden and Number of refugees of Tajikistan?
Make the answer very short. -654. In the year 2013, what is the difference between the Number of refugees of Indonesia and Number of refugees of Lao PDR?
Ensure brevity in your answer.  7041. In the year 2013, what is the difference between the Number of refugees of Indonesia and Number of refugees of Sweden?
Keep it short and to the point. 1.48e+04. In the year 2013, what is the difference between the Number of refugees of Indonesia and Number of refugees of Tajikistan?
Provide a short and direct response. 1.41e+04. In the year 2013, what is the difference between the Number of refugees of Lao PDR and Number of refugees of Sweden?
Your answer should be compact. 7728. In the year 2013, what is the difference between the Number of refugees in Lao PDR and Number of refugees in Tajikistan?
Offer a very short reply. 7084. In the year 2013, what is the difference between the Number of refugees in Sweden and Number of refugees in Tajikistan?
Ensure brevity in your answer.  -644. What is the ratio of the Number of refugees of Indonesia in 2006 to that in 2007?
Provide a short and direct response. 1.69. What is the ratio of the Number of refugees of Lao PDR in 2006 to that in 2007?
Offer a terse response. 2.64. What is the ratio of the Number of refugees in Tajikistan in 2006 to that in 2007?
Your answer should be very brief. 0.72. What is the ratio of the Number of refugees in Indonesia in 2006 to that in 2008?
Keep it short and to the point. 1.8. What is the ratio of the Number of refugees of Lao PDR in 2006 to that in 2008?
Your response must be concise. 3.08. What is the ratio of the Number of refugees in Sweden in 2006 to that in 2008?
Offer a terse response. 1.07. What is the ratio of the Number of refugees of Tajikistan in 2006 to that in 2008?
Give a very brief answer. 1.19. What is the ratio of the Number of refugees of Indonesia in 2006 to that in 2009?
Keep it short and to the point. 1.91. What is the ratio of the Number of refugees in Lao PDR in 2006 to that in 2009?
Your answer should be very brief. 3.15. What is the ratio of the Number of refugees of Sweden in 2006 to that in 2009?
Give a very brief answer. 0.84. What is the ratio of the Number of refugees of Tajikistan in 2006 to that in 2009?
Provide a short and direct response. 1.15. What is the ratio of the Number of refugees of Indonesia in 2006 to that in 2010?
Offer a very short reply. 2.06. What is the ratio of the Number of refugees of Lao PDR in 2006 to that in 2010?
Provide a short and direct response. 3.14. What is the ratio of the Number of refugees in Sweden in 2006 to that in 2010?
Provide a short and direct response. 0.64. What is the ratio of the Number of refugees of Tajikistan in 2006 to that in 2010?
Provide a short and direct response. 1.12. What is the ratio of the Number of refugees in Indonesia in 2006 to that in 2011?
Provide a succinct answer. 2.16. What is the ratio of the Number of refugees in Lao PDR in 2006 to that in 2011?
Ensure brevity in your answer.  3.27. What is the ratio of the Number of refugees in Sweden in 2006 to that in 2011?
Offer a very short reply. 0.67. What is the ratio of the Number of refugees in Tajikistan in 2006 to that in 2011?
Your answer should be compact. 1.05. What is the ratio of the Number of refugees in Indonesia in 2006 to that in 2012?
Your response must be concise. 2.24. What is the ratio of the Number of refugees of Lao PDR in 2006 to that in 2012?
Ensure brevity in your answer.  3.31. What is the ratio of the Number of refugees in Sweden in 2006 to that in 2012?
Ensure brevity in your answer.  0.8. What is the ratio of the Number of refugees of Indonesia in 2006 to that in 2013?
Give a very brief answer. 2.35. What is the ratio of the Number of refugees in Lao PDR in 2006 to that in 2013?
Offer a terse response. 3.41. What is the ratio of the Number of refugees of Tajikistan in 2006 to that in 2013?
Your response must be concise. 0.98. What is the ratio of the Number of refugees in Indonesia in 2007 to that in 2008?
Keep it short and to the point. 1.06. What is the ratio of the Number of refugees in Lao PDR in 2007 to that in 2008?
Keep it short and to the point. 1.16. What is the ratio of the Number of refugees in Sweden in 2007 to that in 2008?
Make the answer very short. 1.07. What is the ratio of the Number of refugees of Tajikistan in 2007 to that in 2008?
Provide a succinct answer. 1.64. What is the ratio of the Number of refugees in Indonesia in 2007 to that in 2009?
Provide a short and direct response. 1.13. What is the ratio of the Number of refugees of Lao PDR in 2007 to that in 2009?
Make the answer very short. 1.19. What is the ratio of the Number of refugees of Sweden in 2007 to that in 2009?
Your response must be concise. 0.84. What is the ratio of the Number of refugees of Tajikistan in 2007 to that in 2009?
Your response must be concise. 1.59. What is the ratio of the Number of refugees in Indonesia in 2007 to that in 2010?
Your answer should be compact. 1.22. What is the ratio of the Number of refugees in Lao PDR in 2007 to that in 2010?
Your answer should be compact. 1.19. What is the ratio of the Number of refugees of Sweden in 2007 to that in 2010?
Provide a short and direct response. 0.64. What is the ratio of the Number of refugees of Tajikistan in 2007 to that in 2010?
Your answer should be compact. 1.55. What is the ratio of the Number of refugees of Indonesia in 2007 to that in 2011?
Give a very brief answer. 1.28. What is the ratio of the Number of refugees of Lao PDR in 2007 to that in 2011?
Your response must be concise. 1.24. What is the ratio of the Number of refugees of Sweden in 2007 to that in 2011?
Your answer should be very brief. 0.67. What is the ratio of the Number of refugees of Tajikistan in 2007 to that in 2011?
Make the answer very short. 1.46. What is the ratio of the Number of refugees in Indonesia in 2007 to that in 2012?
Your answer should be compact. 1.32. What is the ratio of the Number of refugees of Lao PDR in 2007 to that in 2012?
Provide a succinct answer. 1.25. What is the ratio of the Number of refugees of Sweden in 2007 to that in 2012?
Give a very brief answer. 0.8. What is the ratio of the Number of refugees of Tajikistan in 2007 to that in 2012?
Provide a succinct answer. 1.33. What is the ratio of the Number of refugees in Indonesia in 2007 to that in 2013?
Ensure brevity in your answer.  1.39. What is the ratio of the Number of refugees in Lao PDR in 2007 to that in 2013?
Offer a very short reply. 1.29. What is the ratio of the Number of refugees of Tajikistan in 2007 to that in 2013?
Your response must be concise. 1.35. What is the ratio of the Number of refugees in Indonesia in 2008 to that in 2009?
Your answer should be compact. 1.06. What is the ratio of the Number of refugees of Lao PDR in 2008 to that in 2009?
Your response must be concise. 1.02. What is the ratio of the Number of refugees in Sweden in 2008 to that in 2009?
Your response must be concise. 0.79. What is the ratio of the Number of refugees in Indonesia in 2008 to that in 2010?
Offer a very short reply. 1.15. What is the ratio of the Number of refugees of Lao PDR in 2008 to that in 2010?
Give a very brief answer. 1.02. What is the ratio of the Number of refugees of Sweden in 2008 to that in 2010?
Keep it short and to the point. 0.6. What is the ratio of the Number of refugees in Tajikistan in 2008 to that in 2010?
Offer a very short reply. 0.94. What is the ratio of the Number of refugees in Indonesia in 2008 to that in 2011?
Keep it short and to the point. 1.2. What is the ratio of the Number of refugees of Lao PDR in 2008 to that in 2011?
Offer a terse response. 1.06. What is the ratio of the Number of refugees in Sweden in 2008 to that in 2011?
Provide a succinct answer. 0.62. What is the ratio of the Number of refugees in Indonesia in 2008 to that in 2012?
Keep it short and to the point. 1.25. What is the ratio of the Number of refugees of Tajikistan in 2008 to that in 2012?
Offer a terse response. 0.81. What is the ratio of the Number of refugees of Indonesia in 2008 to that in 2013?
Offer a very short reply. 1.31. What is the ratio of the Number of refugees in Lao PDR in 2008 to that in 2013?
Ensure brevity in your answer.  1.11. What is the ratio of the Number of refugees in Sweden in 2008 to that in 2013?
Provide a succinct answer. 0.88. What is the ratio of the Number of refugees of Tajikistan in 2008 to that in 2013?
Keep it short and to the point. 0.82. What is the ratio of the Number of refugees of Indonesia in 2009 to that in 2010?
Offer a very short reply. 1.08. What is the ratio of the Number of refugees of Lao PDR in 2009 to that in 2010?
Your answer should be very brief. 1. What is the ratio of the Number of refugees of Sweden in 2009 to that in 2010?
Your answer should be compact. 0.76. What is the ratio of the Number of refugees in Tajikistan in 2009 to that in 2010?
Provide a succinct answer. 0.97. What is the ratio of the Number of refugees of Indonesia in 2009 to that in 2011?
Make the answer very short. 1.13. What is the ratio of the Number of refugees in Lao PDR in 2009 to that in 2011?
Your answer should be very brief. 1.04. What is the ratio of the Number of refugees of Sweden in 2009 to that in 2011?
Offer a very short reply. 0.79. What is the ratio of the Number of refugees of Tajikistan in 2009 to that in 2011?
Make the answer very short. 0.92. What is the ratio of the Number of refugees in Indonesia in 2009 to that in 2012?
Give a very brief answer. 1.17. What is the ratio of the Number of refugees in Lao PDR in 2009 to that in 2012?
Provide a short and direct response. 1.05. What is the ratio of the Number of refugees of Sweden in 2009 to that in 2012?
Your answer should be compact. 0.95. What is the ratio of the Number of refugees in Tajikistan in 2009 to that in 2012?
Your answer should be very brief. 0.83. What is the ratio of the Number of refugees of Indonesia in 2009 to that in 2013?
Your answer should be very brief. 1.23. What is the ratio of the Number of refugees of Lao PDR in 2009 to that in 2013?
Offer a very short reply. 1.08. What is the ratio of the Number of refugees in Sweden in 2009 to that in 2013?
Offer a terse response. 1.12. What is the ratio of the Number of refugees in Tajikistan in 2009 to that in 2013?
Keep it short and to the point. 0.85. What is the ratio of the Number of refugees in Indonesia in 2010 to that in 2011?
Offer a terse response. 1.05. What is the ratio of the Number of refugees of Lao PDR in 2010 to that in 2011?
Ensure brevity in your answer.  1.04. What is the ratio of the Number of refugees in Sweden in 2010 to that in 2011?
Your response must be concise. 1.04. What is the ratio of the Number of refugees of Tajikistan in 2010 to that in 2011?
Keep it short and to the point. 0.94. What is the ratio of the Number of refugees of Indonesia in 2010 to that in 2012?
Your response must be concise. 1.09. What is the ratio of the Number of refugees of Lao PDR in 2010 to that in 2012?
Your answer should be compact. 1.05. What is the ratio of the Number of refugees in Sweden in 2010 to that in 2012?
Keep it short and to the point. 1.25. What is the ratio of the Number of refugees in Tajikistan in 2010 to that in 2012?
Keep it short and to the point. 0.86. What is the ratio of the Number of refugees of Indonesia in 2010 to that in 2013?
Provide a succinct answer. 1.14. What is the ratio of the Number of refugees in Lao PDR in 2010 to that in 2013?
Your answer should be very brief. 1.09. What is the ratio of the Number of refugees of Sweden in 2010 to that in 2013?
Your response must be concise. 1.47. What is the ratio of the Number of refugees of Tajikistan in 2010 to that in 2013?
Ensure brevity in your answer.  0.87. What is the ratio of the Number of refugees in Indonesia in 2011 to that in 2012?
Your answer should be very brief. 1.04. What is the ratio of the Number of refugees in Lao PDR in 2011 to that in 2012?
Keep it short and to the point. 1.01. What is the ratio of the Number of refugees in Sweden in 2011 to that in 2012?
Provide a short and direct response. 1.2. What is the ratio of the Number of refugees in Tajikistan in 2011 to that in 2012?
Make the answer very short. 0.91. What is the ratio of the Number of refugees in Indonesia in 2011 to that in 2013?
Offer a very short reply. 1.09. What is the ratio of the Number of refugees in Lao PDR in 2011 to that in 2013?
Ensure brevity in your answer.  1.04. What is the ratio of the Number of refugees in Sweden in 2011 to that in 2013?
Ensure brevity in your answer.  1.41. What is the ratio of the Number of refugees of Tajikistan in 2011 to that in 2013?
Ensure brevity in your answer.  0.93. What is the ratio of the Number of refugees of Indonesia in 2012 to that in 2013?
Offer a terse response. 1.05. What is the ratio of the Number of refugees in Lao PDR in 2012 to that in 2013?
Ensure brevity in your answer.  1.03. What is the ratio of the Number of refugees of Sweden in 2012 to that in 2013?
Your response must be concise. 1.18. What is the ratio of the Number of refugees in Tajikistan in 2012 to that in 2013?
Give a very brief answer. 1.02. What is the difference between the highest and the second highest Number of refugees of Indonesia?
Give a very brief answer. 1.42e+04. What is the difference between the highest and the second highest Number of refugees of Lao PDR?
Your answer should be compact. 1.64e+04. What is the difference between the highest and the second highest Number of refugees in Sweden?
Offer a very short reply. 1. What is the difference between the highest and the second highest Number of refugees in Tajikistan?
Your response must be concise. 220. What is the difference between the highest and the lowest Number of refugees in Indonesia?
Give a very brief answer. 1.99e+04. What is the difference between the highest and the lowest Number of refugees in Lao PDR?
Your answer should be very brief. 1.87e+04. What is the difference between the highest and the lowest Number of refugees in Tajikistan?
Ensure brevity in your answer.  350. 